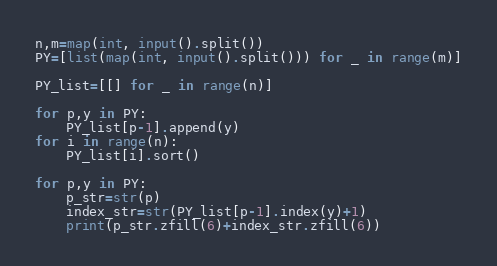Convert code to text. <code><loc_0><loc_0><loc_500><loc_500><_Python_>n,m=map(int, input().split())
PY=[list(map(int, input().split())) for _ in range(m)]

PY_list=[[] for _ in range(n)]

for p,y in PY:
    PY_list[p-1].append(y)
for i in range(n):
    PY_list[i].sort()

for p,y in PY:
    p_str=str(p)
    index_str=str(PY_list[p-1].index(y)+1)
    print(p_str.zfill(6)+index_str.zfill(6)) </code> 